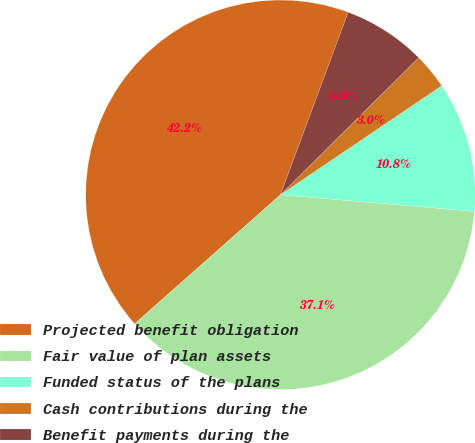Convert chart to OTSL. <chart><loc_0><loc_0><loc_500><loc_500><pie_chart><fcel>Projected benefit obligation<fcel>Fair value of plan assets<fcel>Funded status of the plans<fcel>Cash contributions during the<fcel>Benefit payments during the<nl><fcel>42.18%<fcel>37.11%<fcel>10.82%<fcel>2.98%<fcel>6.9%<nl></chart> 